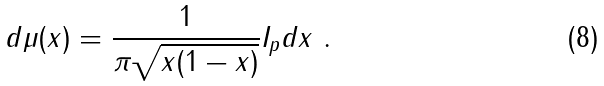Convert formula to latex. <formula><loc_0><loc_0><loc_500><loc_500>d \mu ( x ) = \frac { 1 } { \pi \sqrt { x ( 1 - x ) } } I _ { p } d x \ .</formula> 